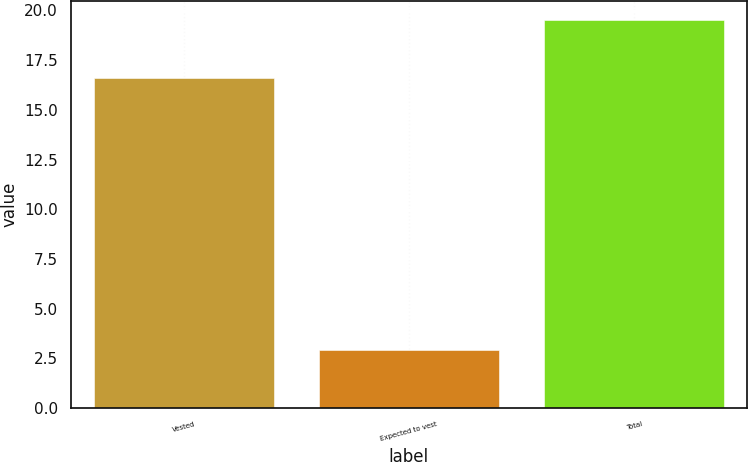<chart> <loc_0><loc_0><loc_500><loc_500><bar_chart><fcel>Vested<fcel>Expected to vest<fcel>Total<nl><fcel>16.6<fcel>2.9<fcel>19.5<nl></chart> 